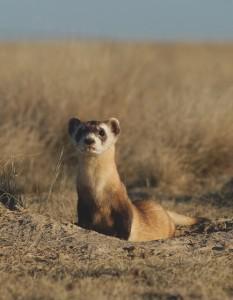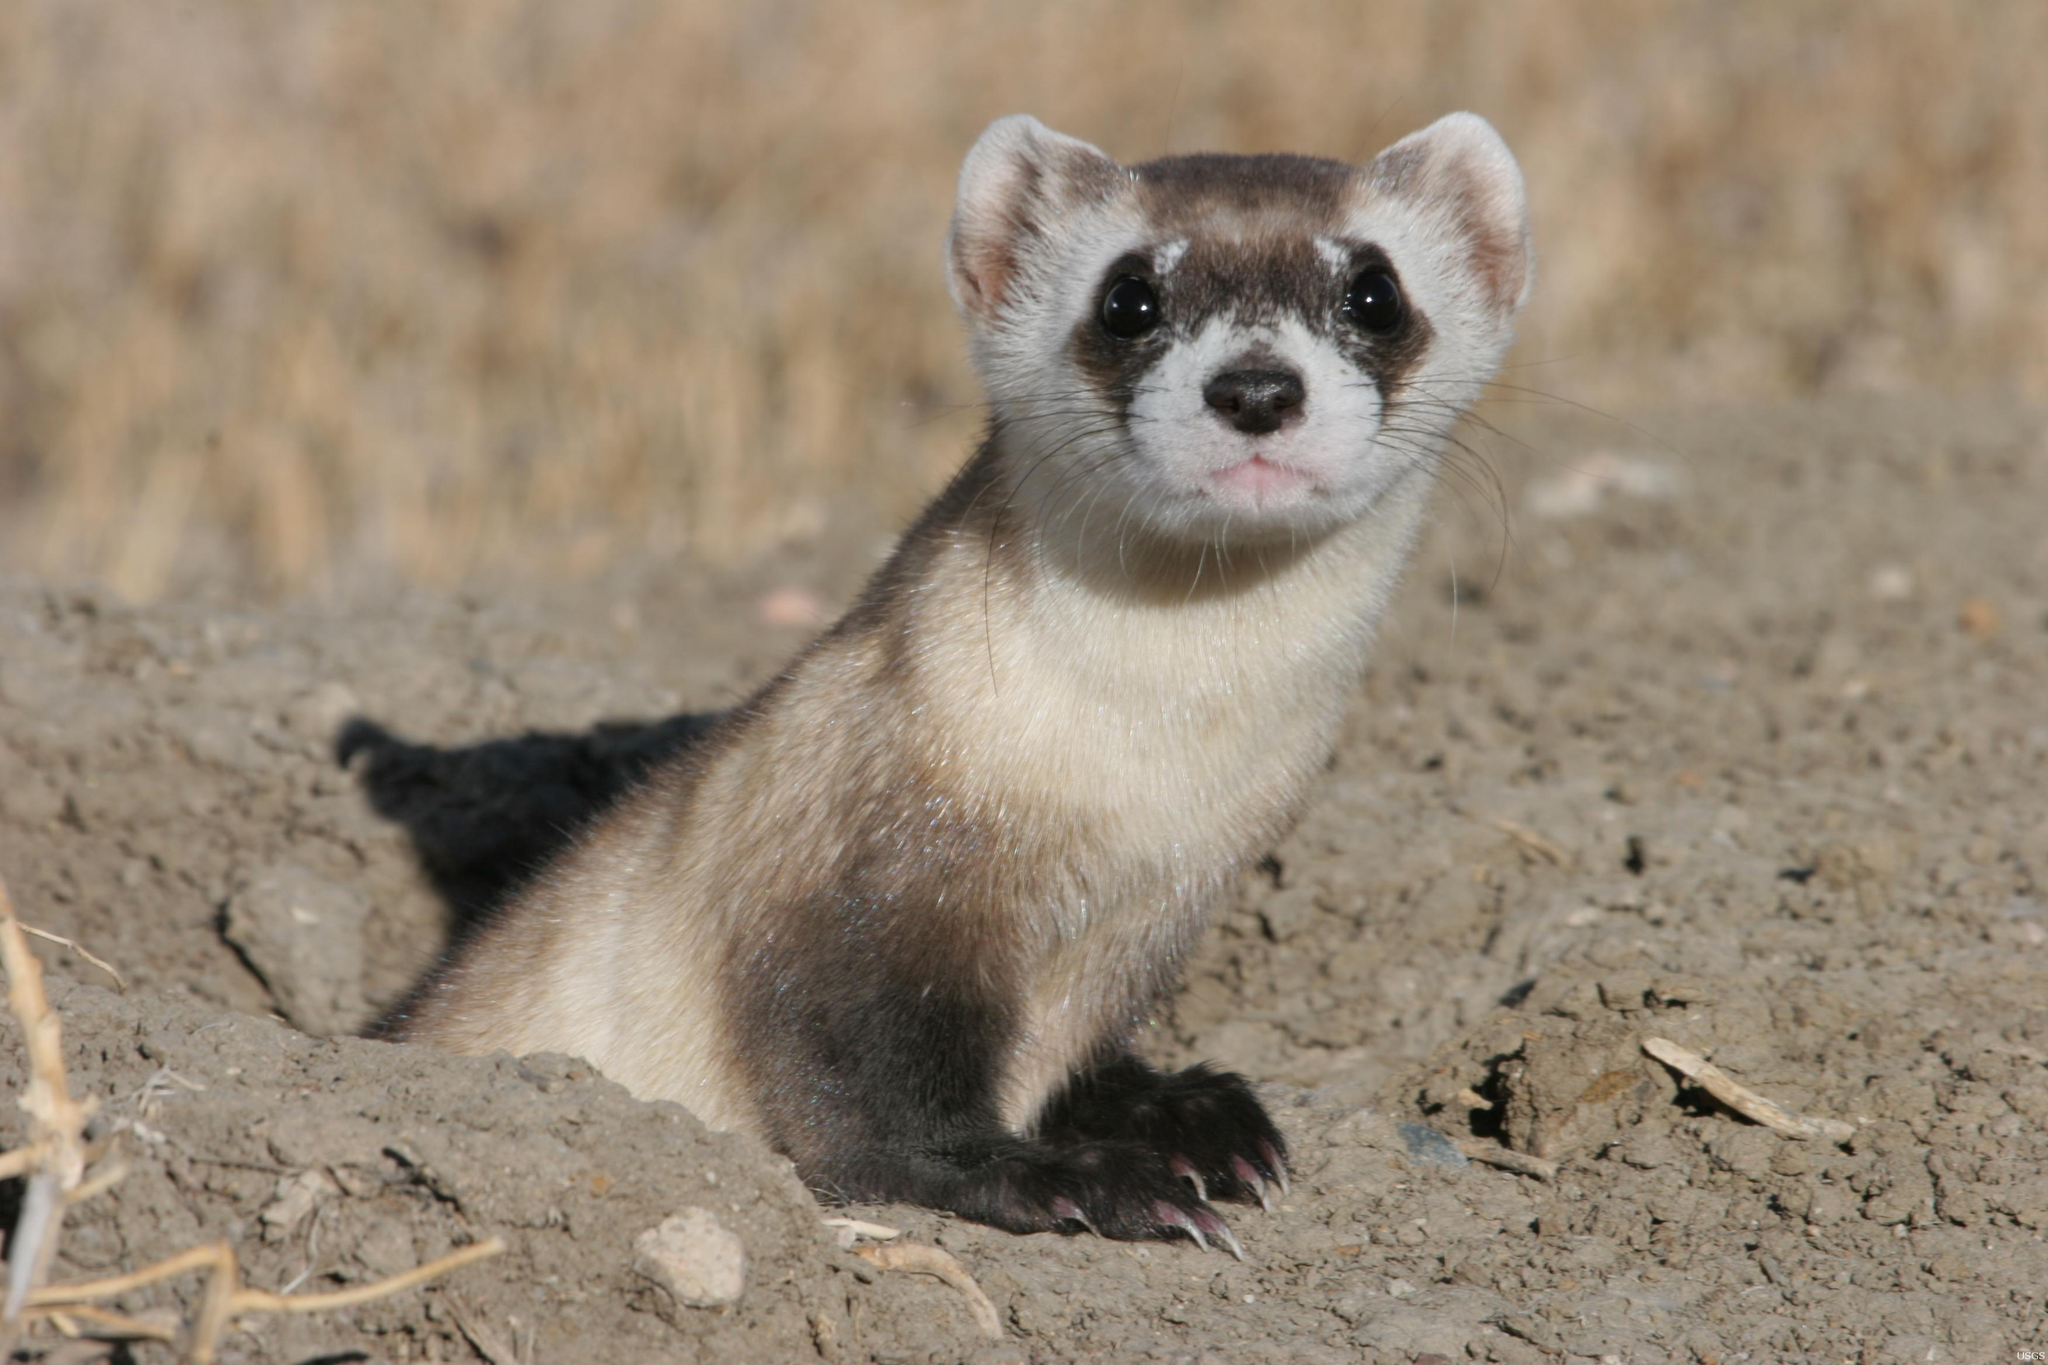The first image is the image on the left, the second image is the image on the right. For the images displayed, is the sentence "An animal in one image is caught leaping in mid-air." factually correct? Answer yes or no. No. The first image is the image on the left, the second image is the image on the right. For the images shown, is this caption "In both images, the ferret's head is stretched up to gaze about." true? Answer yes or no. Yes. 